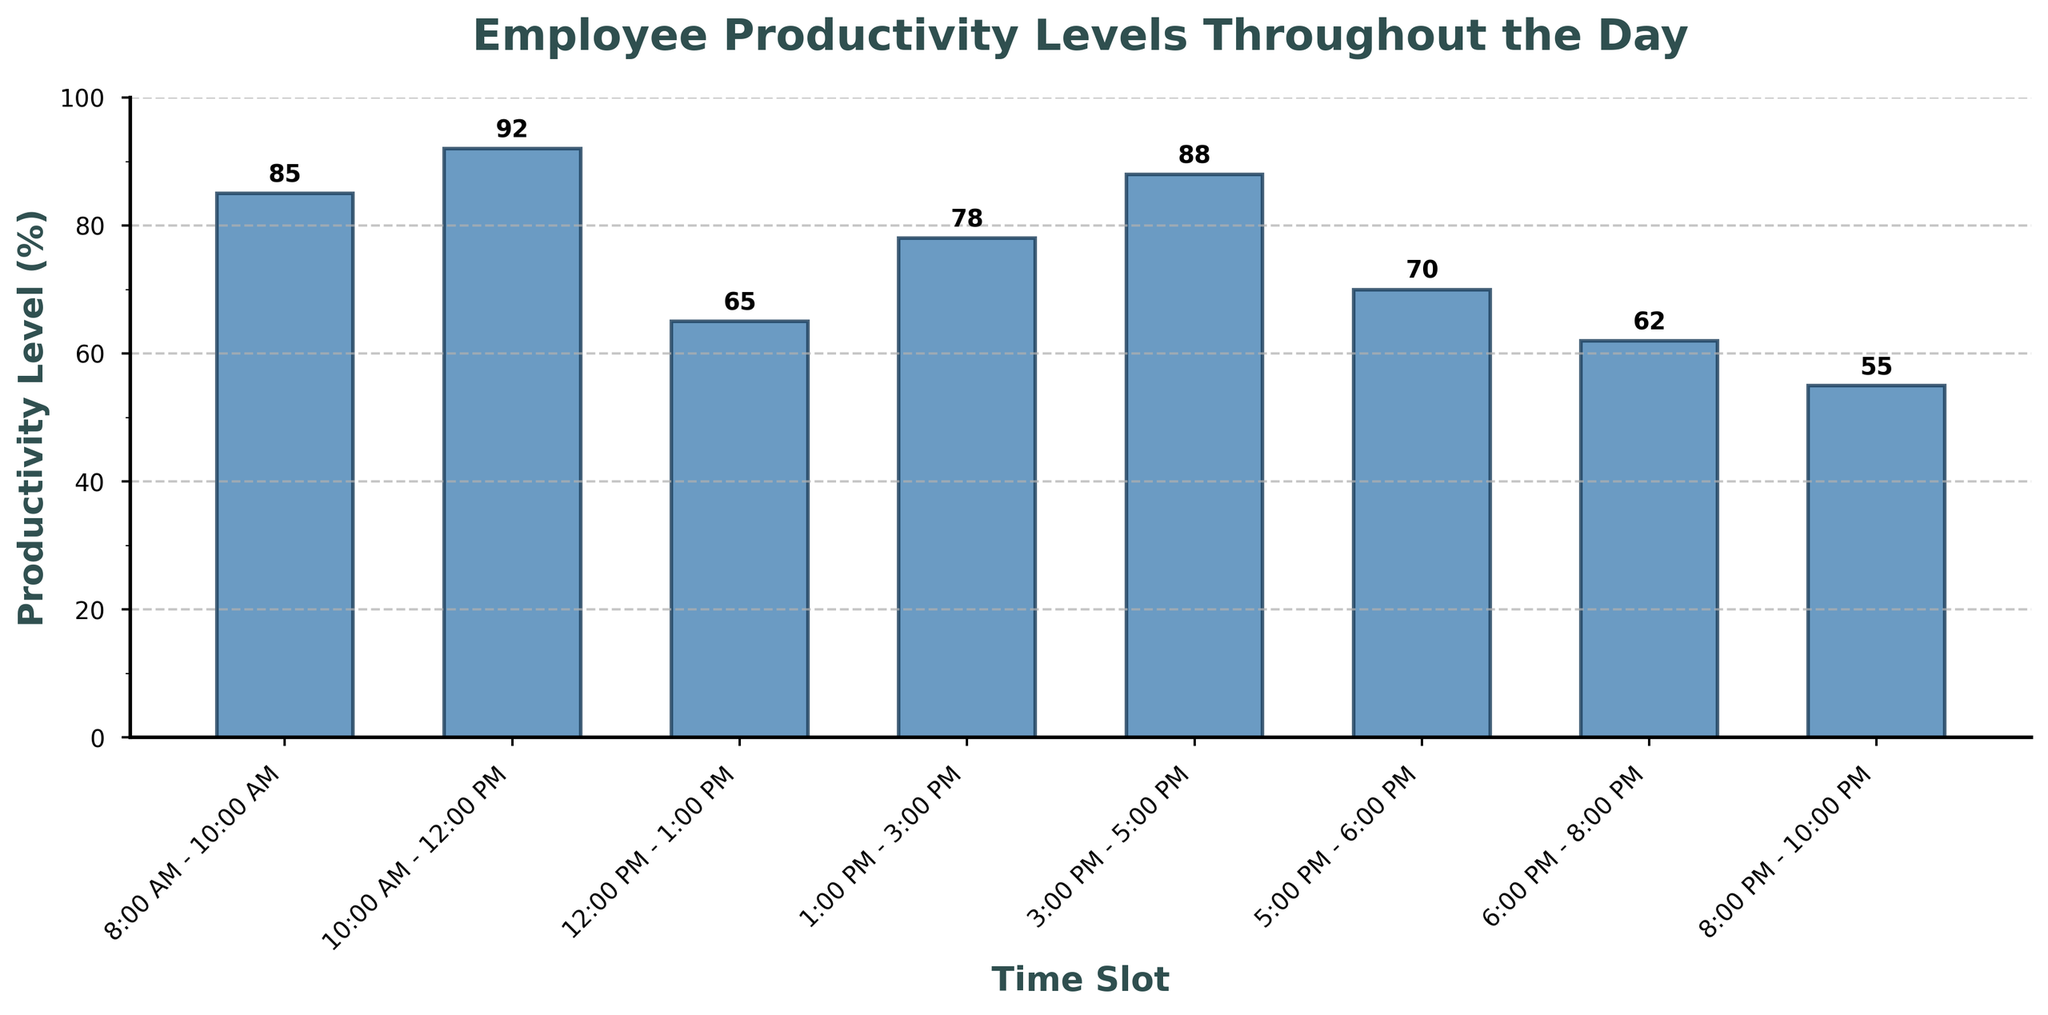What time slot has the highest productivity level? By looking at the heights of the bars, the tallest bar represents the time slot with the highest productivity. The highest bar corresponds to the "10:00 AM - 12:00 PM" slot.
Answer: 10:00 AM - 12:00 PM Comparing the productivity levels at 8:00 AM - 10:00 AM and 3:00 PM - 5:00 PM, which is higher? By comparing the heights of the bars for 8:00 AM - 10:00 AM and 3:00 PM - 5:00 PM, the bar for 3:00 PM - 5:00 PM is taller. The productivity levels are 85% for 8:00 AM - 10:00 AM and 88% for 3:00 PM - 5:00 PM.
Answer: 3:00 PM - 5:00 PM What is the average productivity level from 12:00 PM to 6:00 PM? The productivity levels from 12:00 PM to 6:00 PM are 65%, 78%, 88%, and 70%. Adding these gives 301. Dividing by 4 (number of time slots) results in an average productivity level of 75.25%.
Answer: 75.25% Is the productivity higher or lower at 1:00 PM - 3:00 PM than at 5:00 PM - 6:00 PM? Comparing the heights of the bars for 1:00 PM - 3:00 PM (78%) and 5:00 PM - 6:00 PM (70%), the productivity level is higher at 1:00 PM - 3:00 PM.
Answer: Higher at 1:00 PM - 3:00 PM Which time slot sees a steep decline in productivity from the previous time slot? Observing the changes in bar heights, the productivity drops significantly from "10:00 AM - 12:00 PM" (92%) to "12:00 PM - 1:00 PM" (65%), which corresponds to a steep decline.
Answer: 12:00 PM - 1:00 PM Calculate the total productivity for the entire day. Summing up all the productivity levels: 85 + 92 + 65 + 78 + 88 + 70 + 62 + 55 gives a total productivity of 595%.
Answer: 595% During which time slot is employee productivity at its lowest? The shortest bar indicates the lowest productivity level, which is the "8:00 PM - 10:00 PM" time slot at 55%.
Answer: 8:00 PM - 10:00 PM How much lower is productivity in the 6:00 PM - 8:00 PM slot compared to 3:00 PM - 5:00 PM? Subtracting the productivity level in "6:00 PM - 8:00 PM" (62%) from "3:00 PM - 5:00 PM" (88%) gives a difference of 26%.
Answer: 26% What's the average productivity level for the first four time slots of the day? The productivity levels for the first four time slots are 85, 92, 65, and 78. Adding these gives 320. Dividing by 4 results in an average productivity level of 80%.
Answer: 80% 